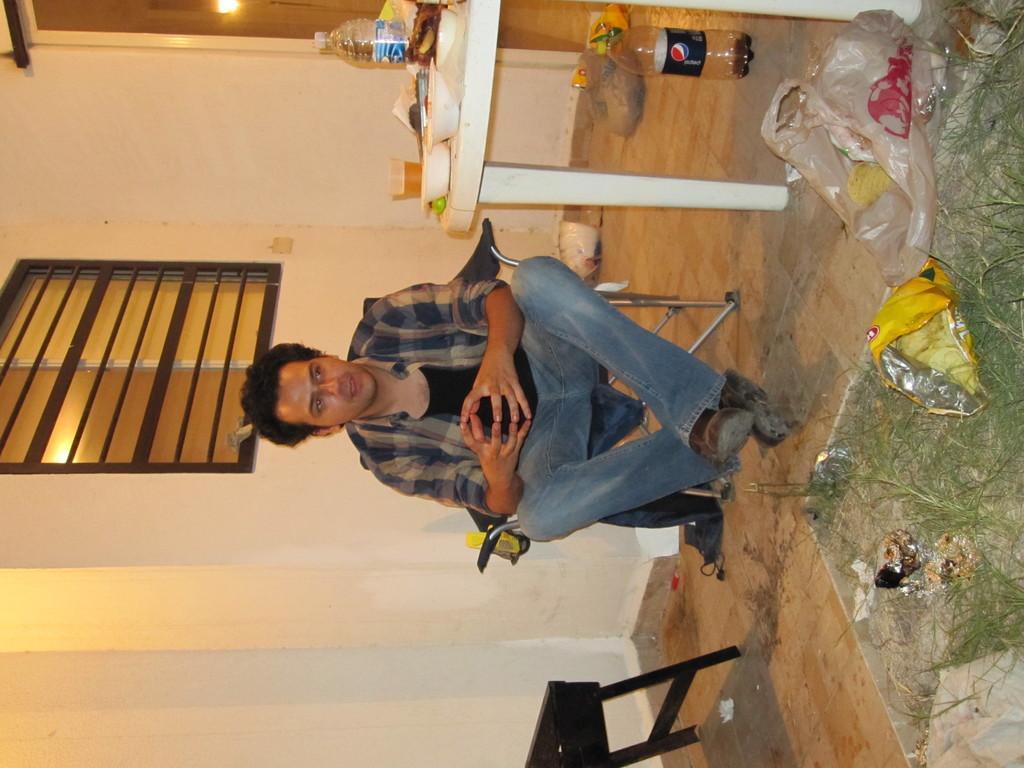Please provide a concise description of this image. In this image, we can see a person sitting. We can see the ground with some objects like a bottle, cover bags and some grass. We can also see a table with some objects like a bottle and some bowls. We can see the wall with the window and some objects attached to it. We can also see a black colored object at the bottom. 